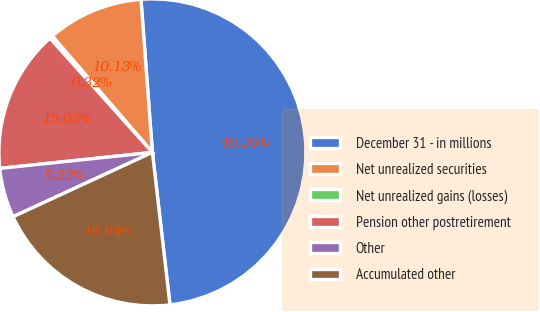Convert chart to OTSL. <chart><loc_0><loc_0><loc_500><loc_500><pie_chart><fcel>December 31 - in millions<fcel>Net unrealized securities<fcel>Net unrealized gains (losses)<fcel>Pension other postretirement<fcel>Other<fcel>Accumulated other<nl><fcel>49.36%<fcel>10.13%<fcel>0.32%<fcel>15.03%<fcel>5.22%<fcel>19.94%<nl></chart> 